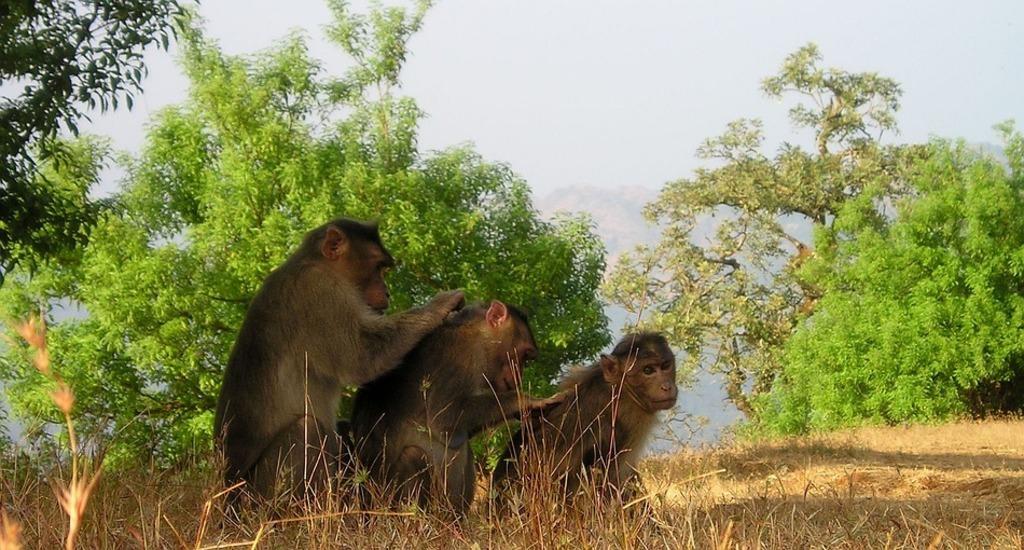How would you summarize this image in a sentence or two? In this image I can see three monkeys in brown and black color. I can see the dry grass and the sky. I can see few trees in green color. 